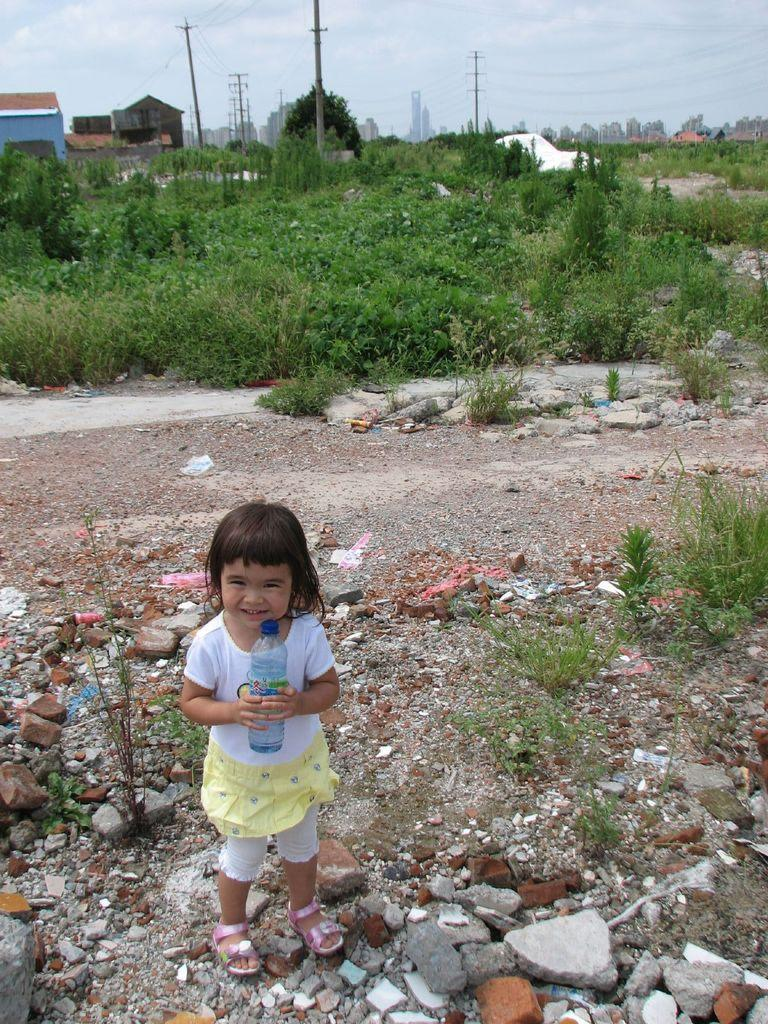What is the girl in the image holding? The girl is holding a bottle. What type of natural features can be seen in the image? There are rocks, plants, and trees in the image. What type of man-made structures are visible in the image? There are houses and poles in the image. What is present in the image that might be used for transmitting electricity or communication signals? There are cables in the image. What can be seen in the background of the image? The sky is visible in the background of the image. Can you tell me how many strangers are present in the image? There is no stranger present in the image; the girl is the only person visible. What type of island can be seen in the image? There is no island present in the image. 